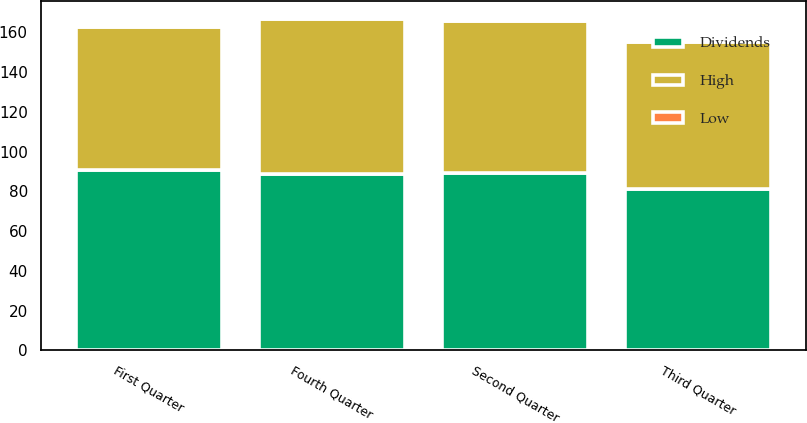<chart> <loc_0><loc_0><loc_500><loc_500><stacked_bar_chart><ecel><fcel>First Quarter<fcel>Second Quarter<fcel>Third Quarter<fcel>Fourth Quarter<nl><fcel>Dividends<fcel>90.87<fcel>89.31<fcel>81.31<fcel>88.87<nl><fcel>High<fcel>71.74<fcel>76.4<fcel>73.67<fcel>77.66<nl><fcel>Low<fcel>0.56<fcel>0.63<fcel>0.63<fcel>0.63<nl></chart> 